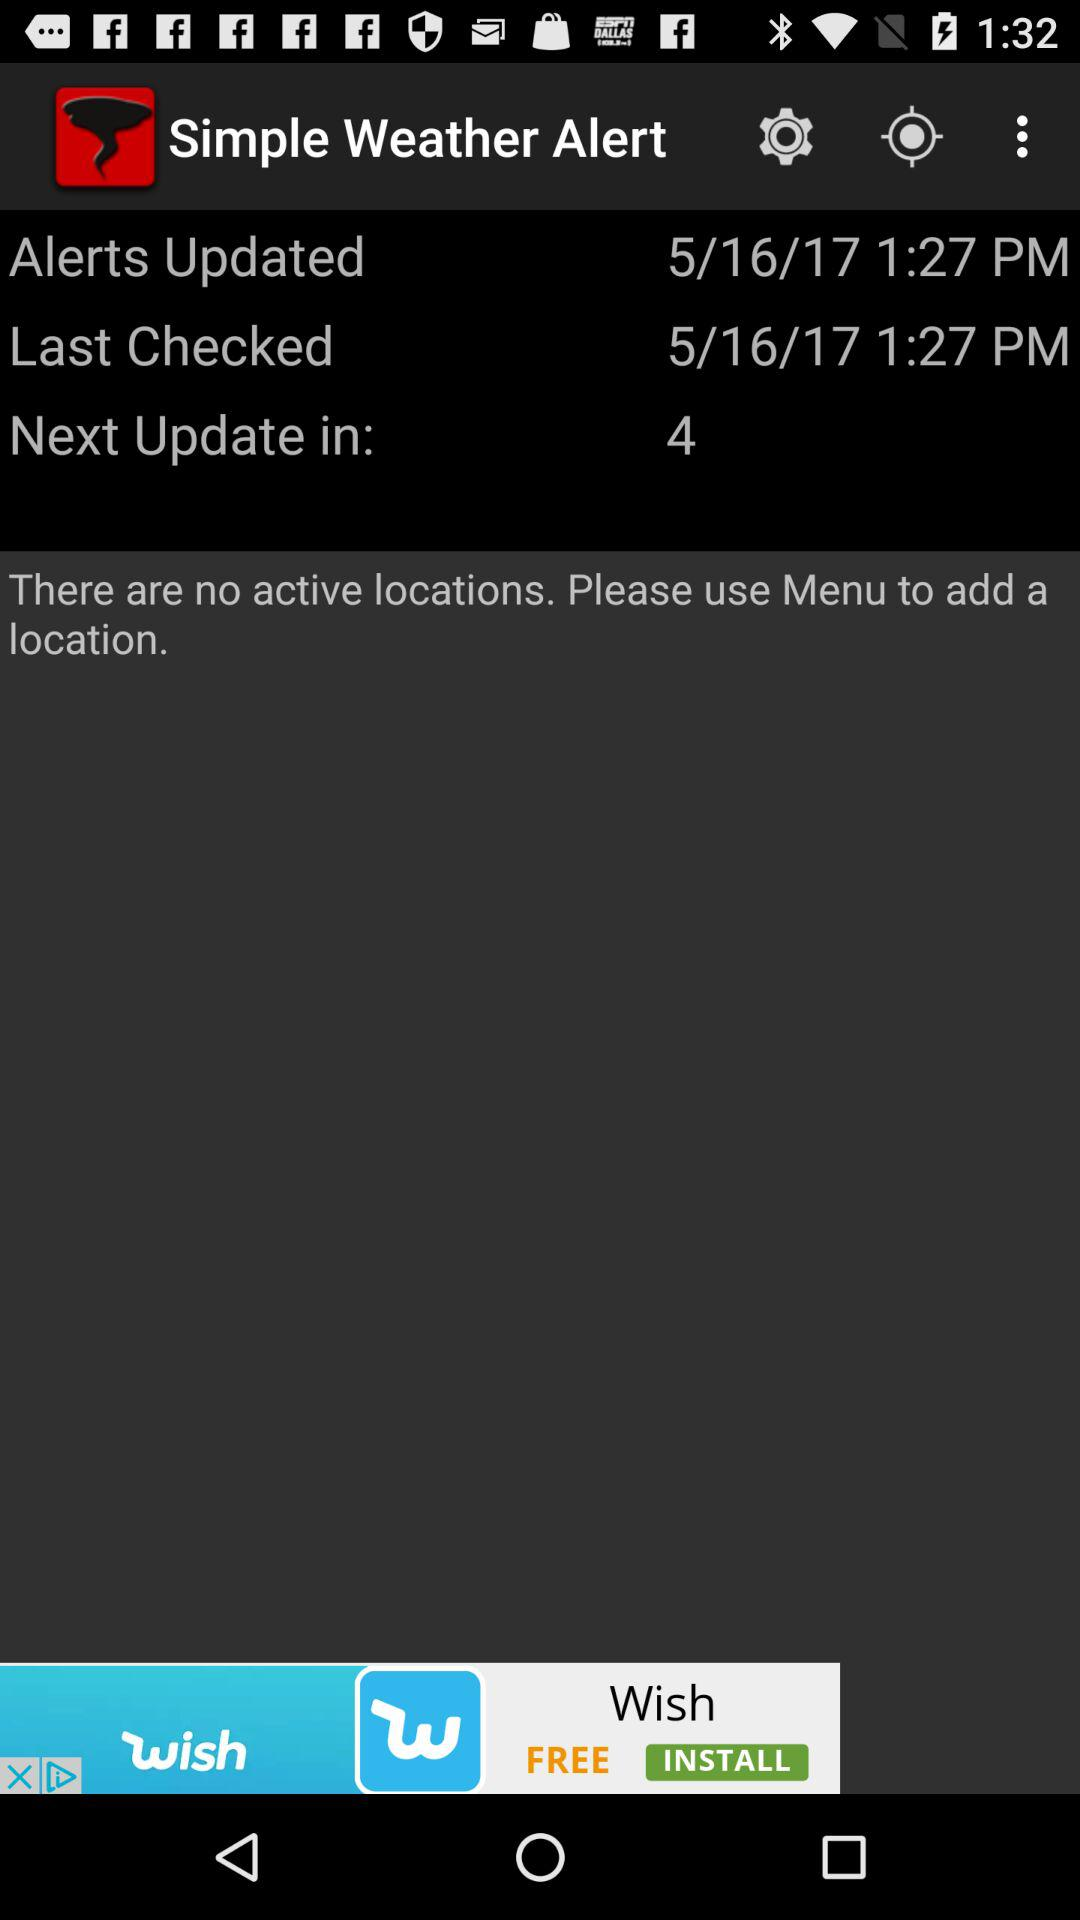When is the next update? The next update is in 4. 